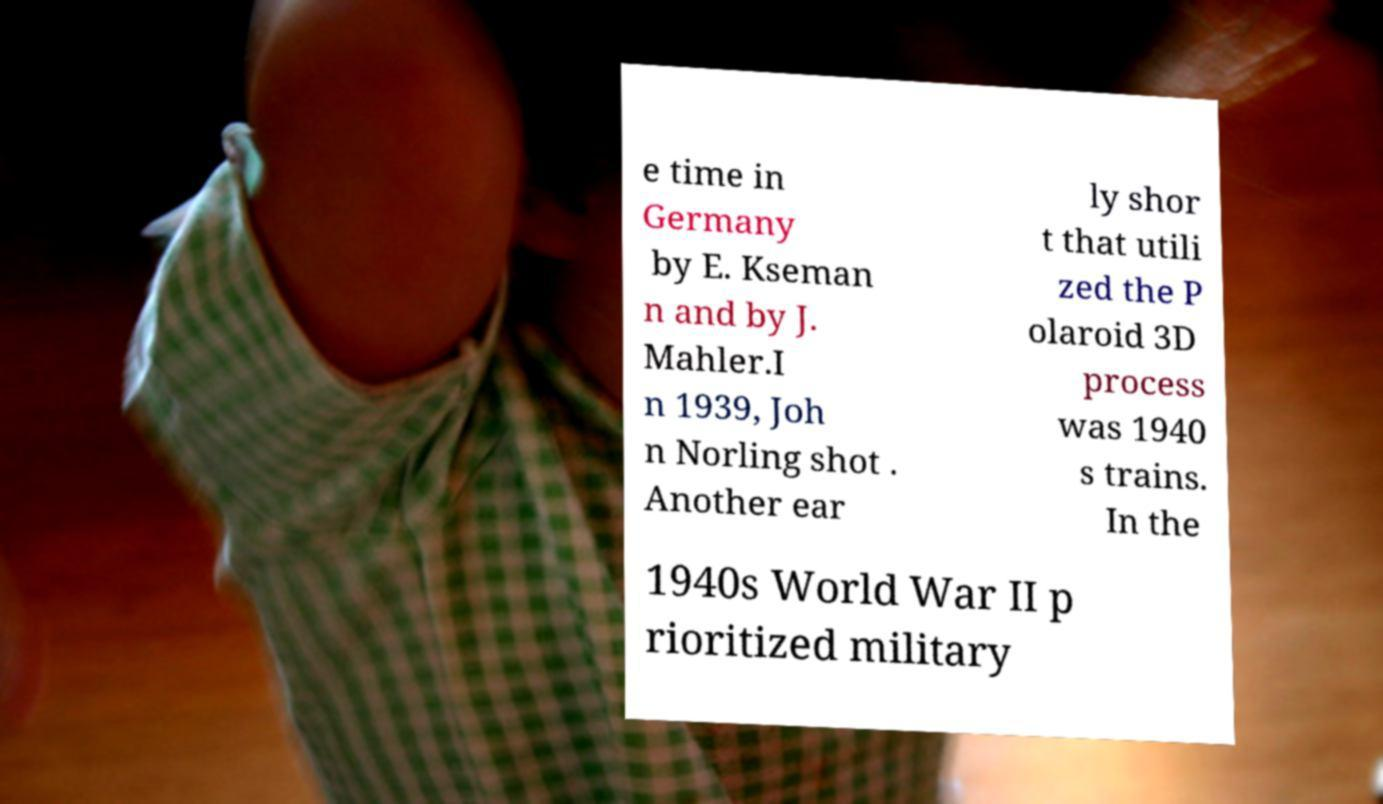I need the written content from this picture converted into text. Can you do that? e time in Germany by E. Kseman n and by J. Mahler.I n 1939, Joh n Norling shot . Another ear ly shor t that utili zed the P olaroid 3D process was 1940 s trains. In the 1940s World War II p rioritized military 